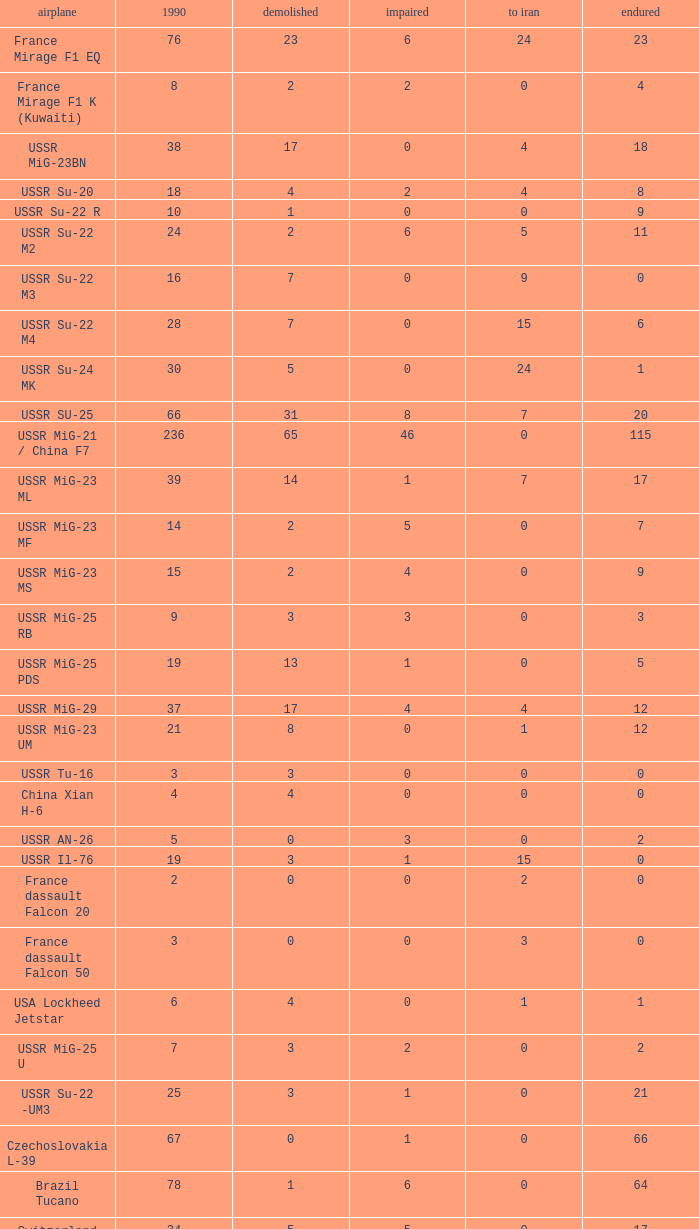If the aircraft was  ussr mig-25 rb how many were destroyed? 3.0. 